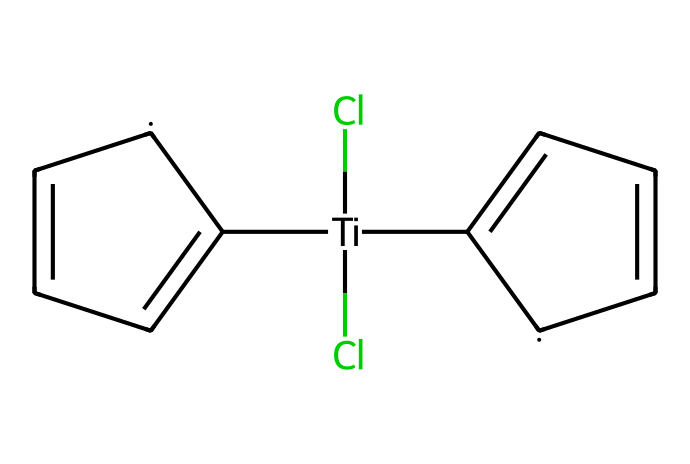What is the central metal in titanocene dichloride? The chemical structure indicates that titanium (Ti) is the central metal atom surrounded by chlorines and organic groups.
Answer: titanium How many chlorine atoms are present in titanocene dichloride? Analyzing the SMILES representation, there are two chlorine (Cl) atoms attached to the titanium center.
Answer: 2 What type of organometallic compound is titanocene dichloride classified as? Titanocene dichloride is classified as a metallocene due to its sandwich structure, where a metal is sandwiched between cyclopentadienyl ligands.
Answer: metallocene How many aromatic rings are present in titanocene dichloride? The chemical structure shows two phenyl (aromatic) rings, as deduced from the two C=C connections in the structure.
Answer: 2 What is the degree of saturation of the cyclopentadienyl ligands in this compound? The cyclopentadienyl ligands are fully aromatic and thus fully saturated, contributing to a total of 5 carbons each in cyclic structures contributing only to delocalized pi-bonding.
Answer: fully saturated How does titanocene dichloride contribute to durability in film reels? Titanocene dichloride imparts significant thermal stability and resilience to films, which is crucial in enhancing the performance and longevity of film reels.
Answer: stability 